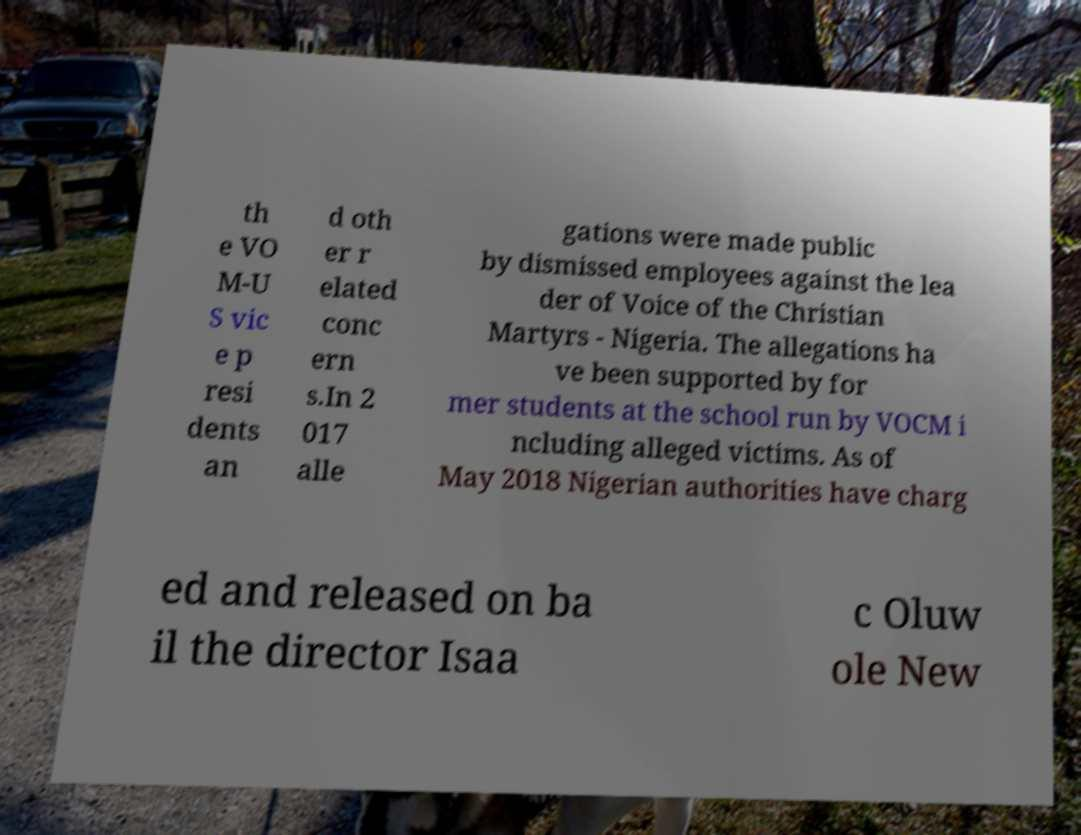Could you assist in decoding the text presented in this image and type it out clearly? th e VO M-U S vic e p resi dents an d oth er r elated conc ern s.In 2 017 alle gations were made public by dismissed employees against the lea der of Voice of the Christian Martyrs - Nigeria. The allegations ha ve been supported by for mer students at the school run by VOCM i ncluding alleged victims. As of May 2018 Nigerian authorities have charg ed and released on ba il the director Isaa c Oluw ole New 